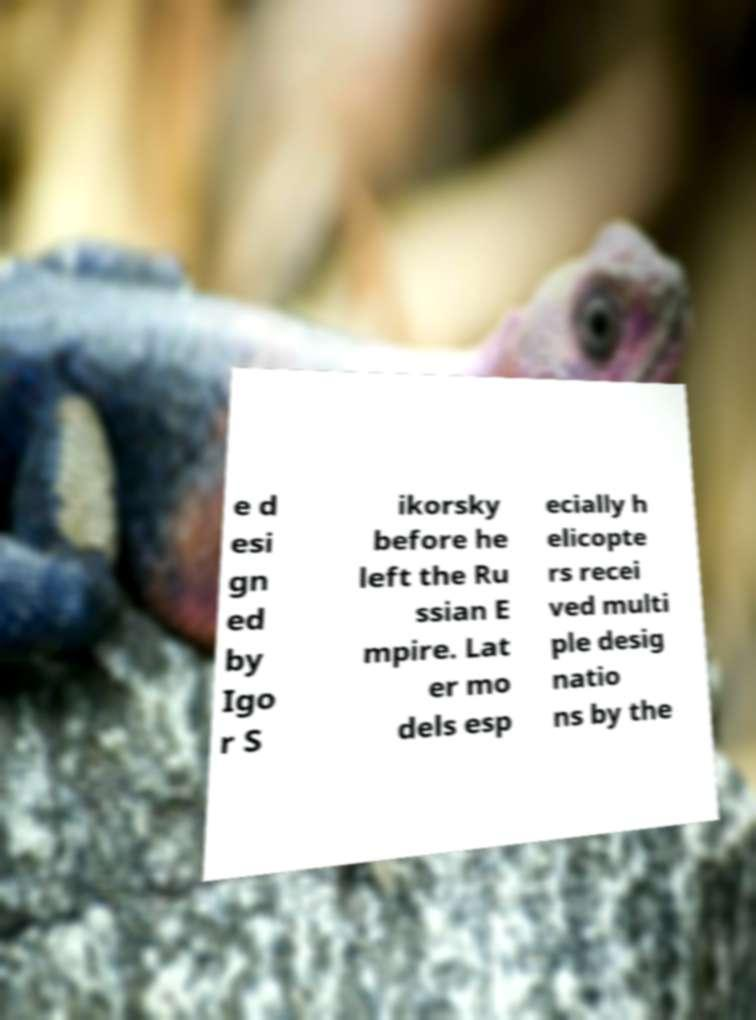Can you read and provide the text displayed in the image?This photo seems to have some interesting text. Can you extract and type it out for me? e d esi gn ed by Igo r S ikorsky before he left the Ru ssian E mpire. Lat er mo dels esp ecially h elicopte rs recei ved multi ple desig natio ns by the 